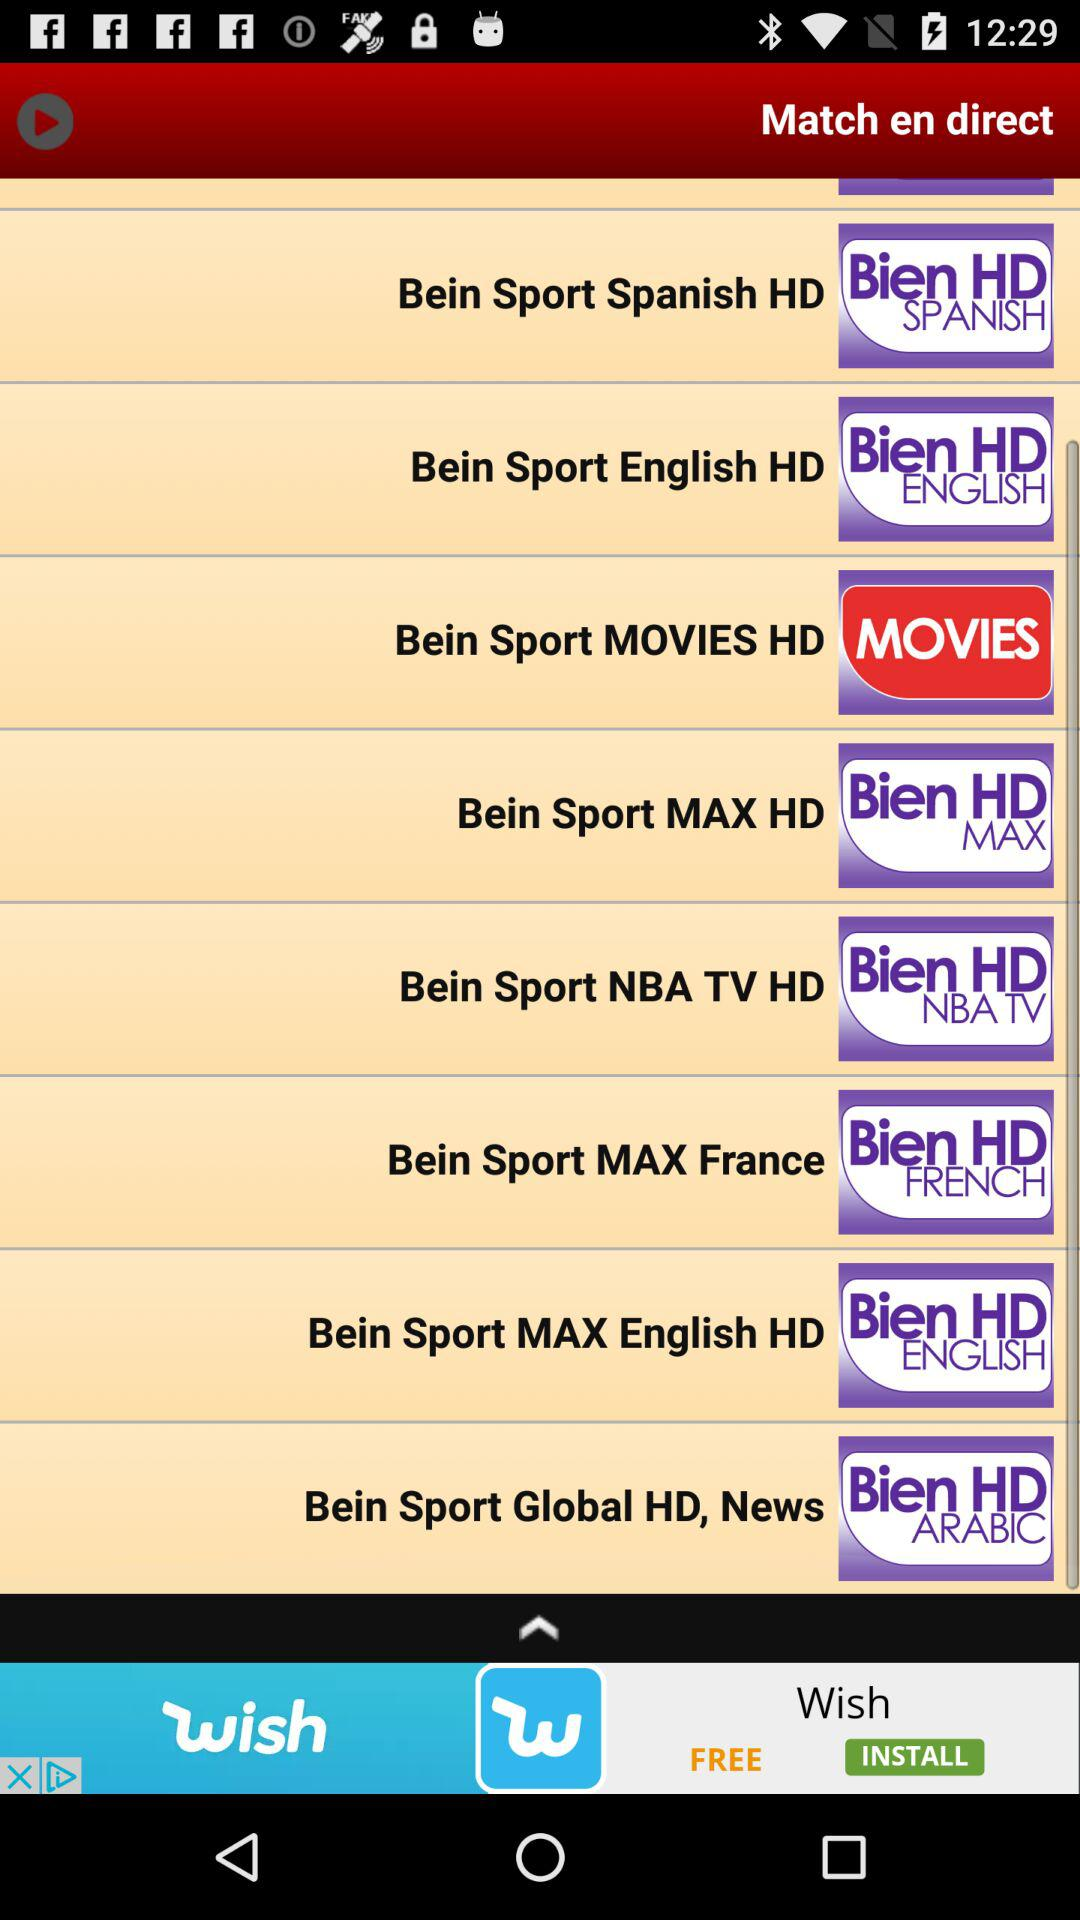How many Bein Sport channels are in the English language?
Answer the question using a single word or phrase. 2 